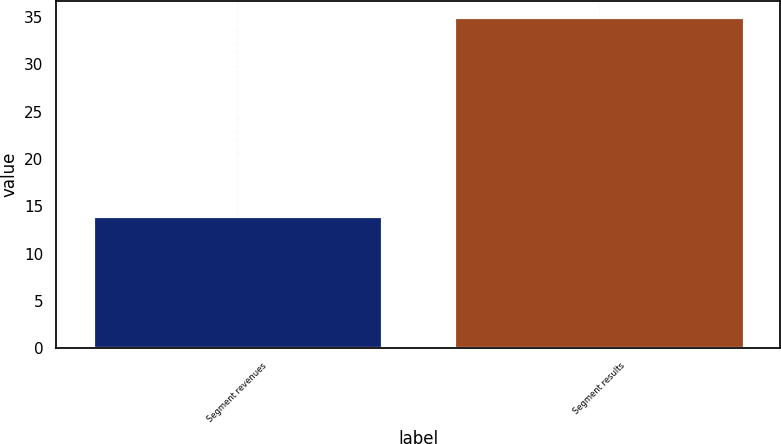Convert chart to OTSL. <chart><loc_0><loc_0><loc_500><loc_500><bar_chart><fcel>Segment revenues<fcel>Segment results<nl><fcel>14<fcel>35<nl></chart> 